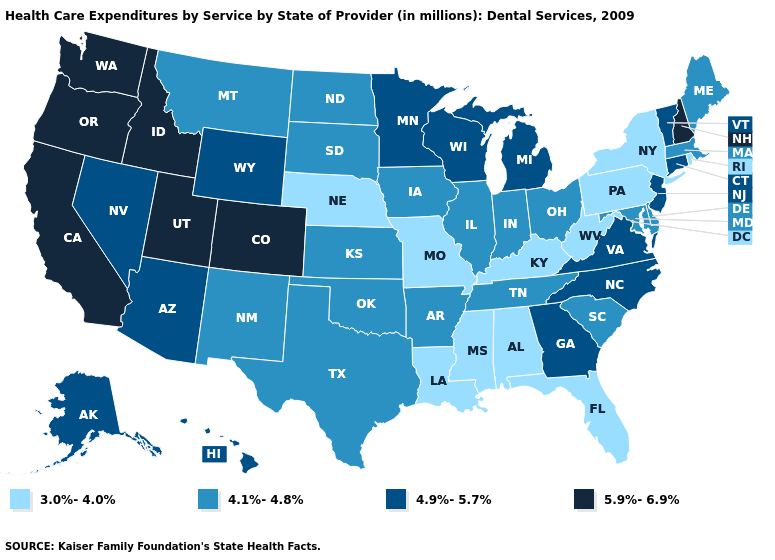What is the lowest value in the Northeast?
Concise answer only. 3.0%-4.0%. Among the states that border Massachusetts , does Rhode Island have the lowest value?
Quick response, please. Yes. What is the value of Missouri?
Write a very short answer. 3.0%-4.0%. Does Florida have a lower value than Louisiana?
Concise answer only. No. Name the states that have a value in the range 3.0%-4.0%?
Short answer required. Alabama, Florida, Kentucky, Louisiana, Mississippi, Missouri, Nebraska, New York, Pennsylvania, Rhode Island, West Virginia. What is the value of Missouri?
Give a very brief answer. 3.0%-4.0%. Name the states that have a value in the range 4.9%-5.7%?
Answer briefly. Alaska, Arizona, Connecticut, Georgia, Hawaii, Michigan, Minnesota, Nevada, New Jersey, North Carolina, Vermont, Virginia, Wisconsin, Wyoming. Does the first symbol in the legend represent the smallest category?
Answer briefly. Yes. What is the lowest value in the West?
Write a very short answer. 4.1%-4.8%. Among the states that border Tennessee , which have the highest value?
Keep it brief. Georgia, North Carolina, Virginia. Which states have the highest value in the USA?
Be succinct. California, Colorado, Idaho, New Hampshire, Oregon, Utah, Washington. Is the legend a continuous bar?
Be succinct. No. What is the value of Kansas?
Be succinct. 4.1%-4.8%. What is the value of Minnesota?
Concise answer only. 4.9%-5.7%. What is the lowest value in states that border South Carolina?
Be succinct. 4.9%-5.7%. 